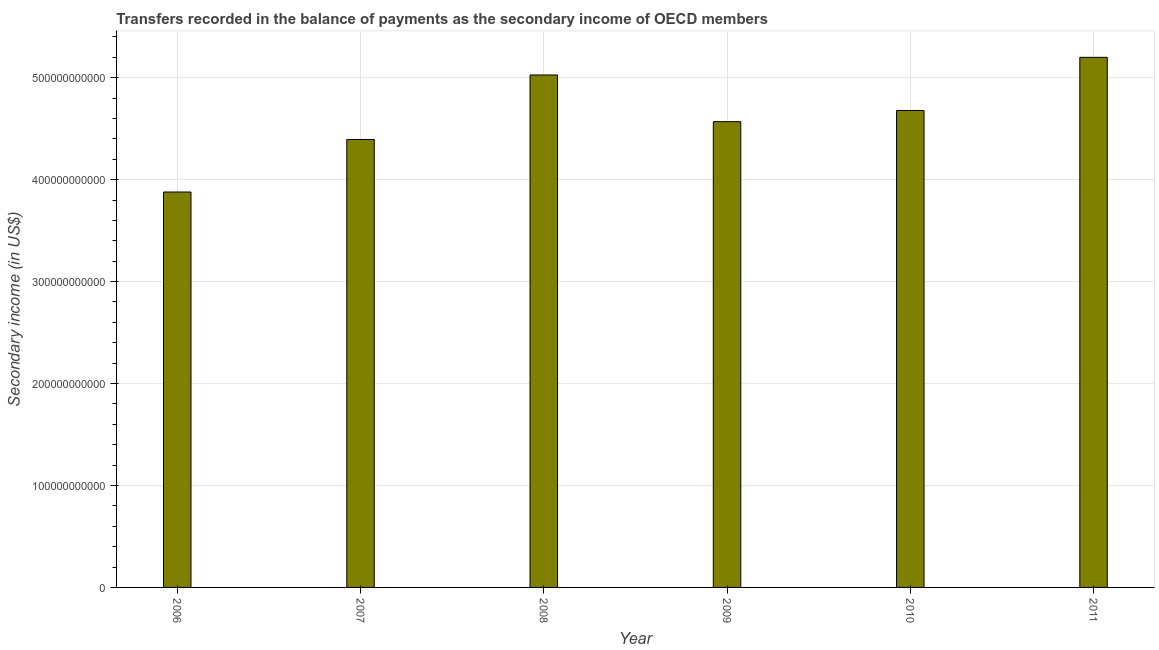Does the graph contain any zero values?
Make the answer very short. No. Does the graph contain grids?
Provide a succinct answer. Yes. What is the title of the graph?
Ensure brevity in your answer.  Transfers recorded in the balance of payments as the secondary income of OECD members. What is the label or title of the X-axis?
Offer a very short reply. Year. What is the label or title of the Y-axis?
Provide a short and direct response. Secondary income (in US$). What is the amount of secondary income in 2008?
Your response must be concise. 5.03e+11. Across all years, what is the maximum amount of secondary income?
Offer a very short reply. 5.20e+11. Across all years, what is the minimum amount of secondary income?
Your answer should be very brief. 3.88e+11. In which year was the amount of secondary income minimum?
Provide a short and direct response. 2006. What is the sum of the amount of secondary income?
Offer a terse response. 2.77e+12. What is the difference between the amount of secondary income in 2009 and 2011?
Offer a very short reply. -6.31e+1. What is the average amount of secondary income per year?
Provide a succinct answer. 4.62e+11. What is the median amount of secondary income?
Provide a short and direct response. 4.62e+11. In how many years, is the amount of secondary income greater than 120000000000 US$?
Your answer should be very brief. 6. Do a majority of the years between 2011 and 2006 (inclusive) have amount of secondary income greater than 520000000000 US$?
Offer a very short reply. Yes. Is the difference between the amount of secondary income in 2008 and 2009 greater than the difference between any two years?
Keep it short and to the point. No. What is the difference between the highest and the second highest amount of secondary income?
Make the answer very short. 1.73e+1. What is the difference between the highest and the lowest amount of secondary income?
Keep it short and to the point. 1.32e+11. In how many years, is the amount of secondary income greater than the average amount of secondary income taken over all years?
Your answer should be very brief. 3. Are all the bars in the graph horizontal?
Offer a terse response. No. How many years are there in the graph?
Your answer should be compact. 6. What is the difference between two consecutive major ticks on the Y-axis?
Ensure brevity in your answer.  1.00e+11. What is the Secondary income (in US$) of 2006?
Provide a short and direct response. 3.88e+11. What is the Secondary income (in US$) in 2007?
Your answer should be very brief. 4.39e+11. What is the Secondary income (in US$) of 2008?
Your answer should be compact. 5.03e+11. What is the Secondary income (in US$) in 2009?
Your answer should be compact. 4.57e+11. What is the Secondary income (in US$) of 2010?
Your answer should be compact. 4.68e+11. What is the Secondary income (in US$) of 2011?
Ensure brevity in your answer.  5.20e+11. What is the difference between the Secondary income (in US$) in 2006 and 2007?
Your answer should be very brief. -5.15e+1. What is the difference between the Secondary income (in US$) in 2006 and 2008?
Your response must be concise. -1.15e+11. What is the difference between the Secondary income (in US$) in 2006 and 2009?
Provide a succinct answer. -6.90e+1. What is the difference between the Secondary income (in US$) in 2006 and 2010?
Your answer should be very brief. -8.00e+1. What is the difference between the Secondary income (in US$) in 2006 and 2011?
Provide a succinct answer. -1.32e+11. What is the difference between the Secondary income (in US$) in 2007 and 2008?
Make the answer very short. -6.33e+1. What is the difference between the Secondary income (in US$) in 2007 and 2009?
Keep it short and to the point. -1.75e+1. What is the difference between the Secondary income (in US$) in 2007 and 2010?
Your response must be concise. -2.84e+1. What is the difference between the Secondary income (in US$) in 2007 and 2011?
Give a very brief answer. -8.06e+1. What is the difference between the Secondary income (in US$) in 2008 and 2009?
Your response must be concise. 4.58e+1. What is the difference between the Secondary income (in US$) in 2008 and 2010?
Give a very brief answer. 3.48e+1. What is the difference between the Secondary income (in US$) in 2008 and 2011?
Ensure brevity in your answer.  -1.73e+1. What is the difference between the Secondary income (in US$) in 2009 and 2010?
Offer a very short reply. -1.10e+1. What is the difference between the Secondary income (in US$) in 2009 and 2011?
Make the answer very short. -6.31e+1. What is the difference between the Secondary income (in US$) in 2010 and 2011?
Your response must be concise. -5.22e+1. What is the ratio of the Secondary income (in US$) in 2006 to that in 2007?
Provide a short and direct response. 0.88. What is the ratio of the Secondary income (in US$) in 2006 to that in 2008?
Your answer should be very brief. 0.77. What is the ratio of the Secondary income (in US$) in 2006 to that in 2009?
Provide a succinct answer. 0.85. What is the ratio of the Secondary income (in US$) in 2006 to that in 2010?
Provide a short and direct response. 0.83. What is the ratio of the Secondary income (in US$) in 2006 to that in 2011?
Offer a very short reply. 0.75. What is the ratio of the Secondary income (in US$) in 2007 to that in 2008?
Your answer should be compact. 0.87. What is the ratio of the Secondary income (in US$) in 2007 to that in 2009?
Make the answer very short. 0.96. What is the ratio of the Secondary income (in US$) in 2007 to that in 2010?
Your response must be concise. 0.94. What is the ratio of the Secondary income (in US$) in 2007 to that in 2011?
Your response must be concise. 0.84. What is the ratio of the Secondary income (in US$) in 2008 to that in 2010?
Give a very brief answer. 1.07. What is the ratio of the Secondary income (in US$) in 2008 to that in 2011?
Your answer should be compact. 0.97. What is the ratio of the Secondary income (in US$) in 2009 to that in 2010?
Your answer should be very brief. 0.98. What is the ratio of the Secondary income (in US$) in 2009 to that in 2011?
Provide a succinct answer. 0.88. 